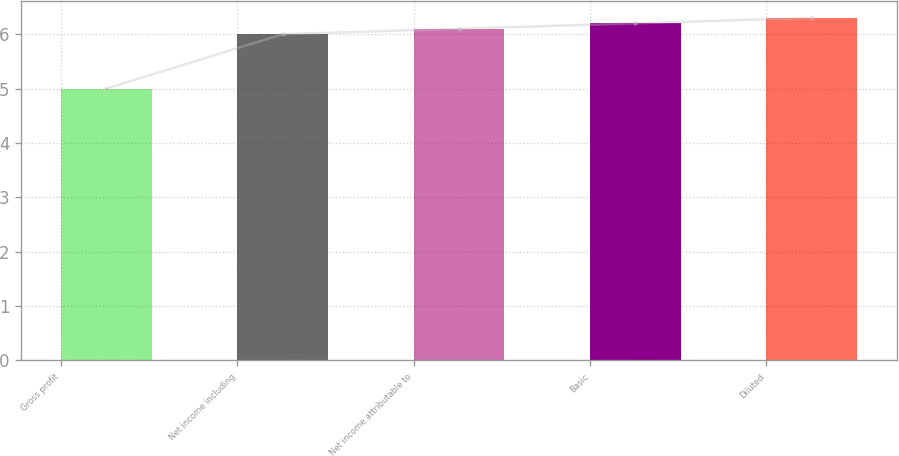Convert chart to OTSL. <chart><loc_0><loc_0><loc_500><loc_500><bar_chart><fcel>Gross profit<fcel>Net income including<fcel>Net income attributable to<fcel>Basic<fcel>Diluted<nl><fcel>5<fcel>6<fcel>6.1<fcel>6.2<fcel>6.3<nl></chart> 